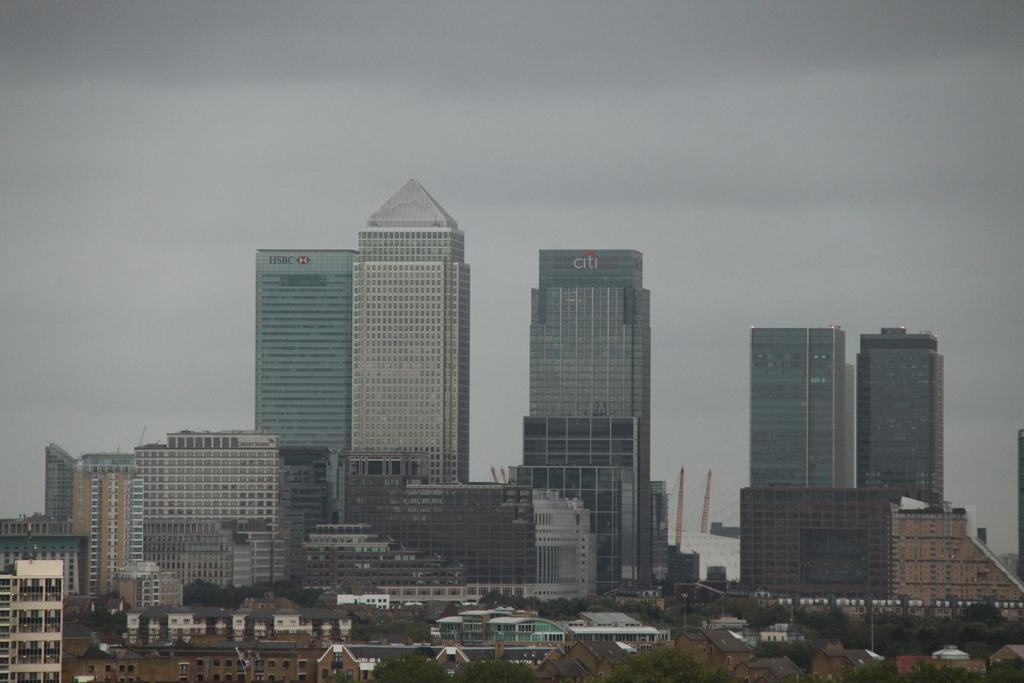Describe this image in one or two sentences. In this picture we can see many buildings, few poles, trees and towers in the background. 